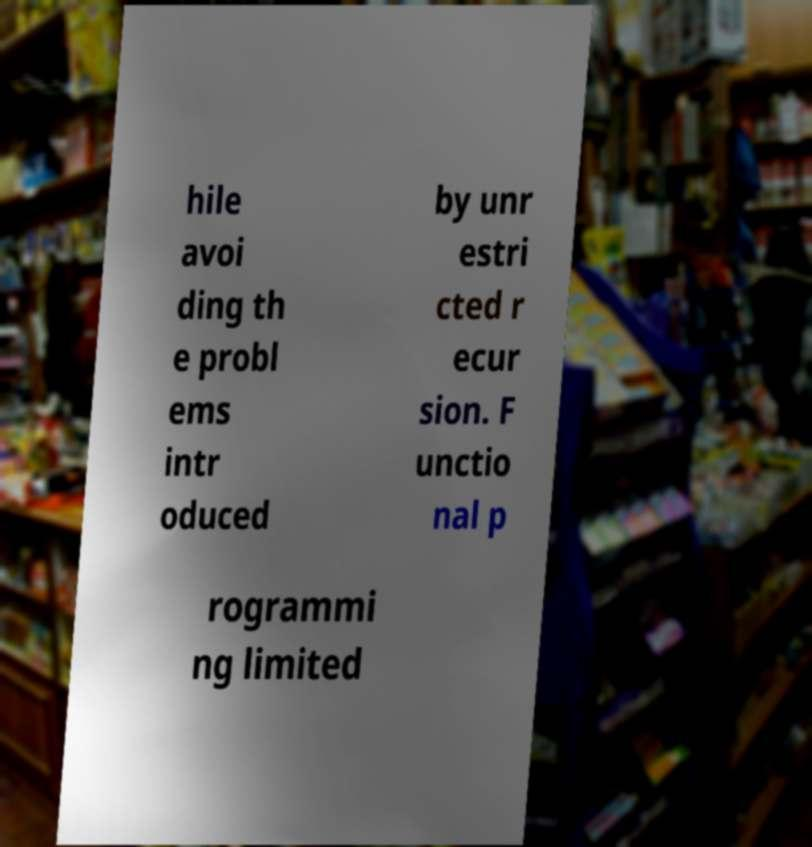Can you accurately transcribe the text from the provided image for me? hile avoi ding th e probl ems intr oduced by unr estri cted r ecur sion. F unctio nal p rogrammi ng limited 